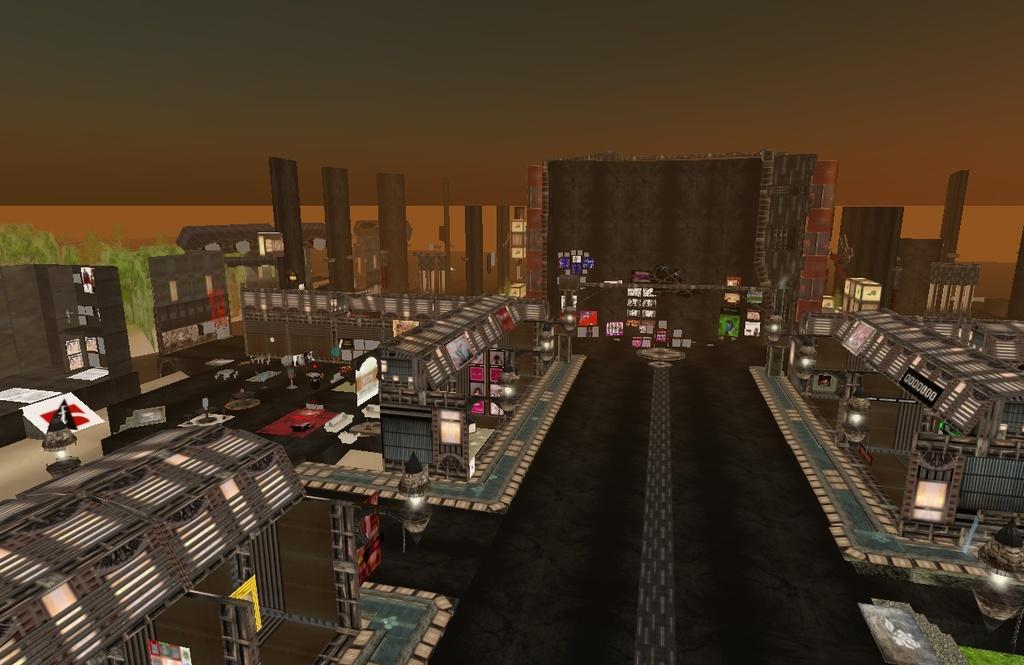How would you summarize this image in a sentence or two? In this image I can see the miniature. I can see the road. To the side of the road there are buildings. And in the back I can see few more buildings and trees. And I can see some boards to the buildings. 